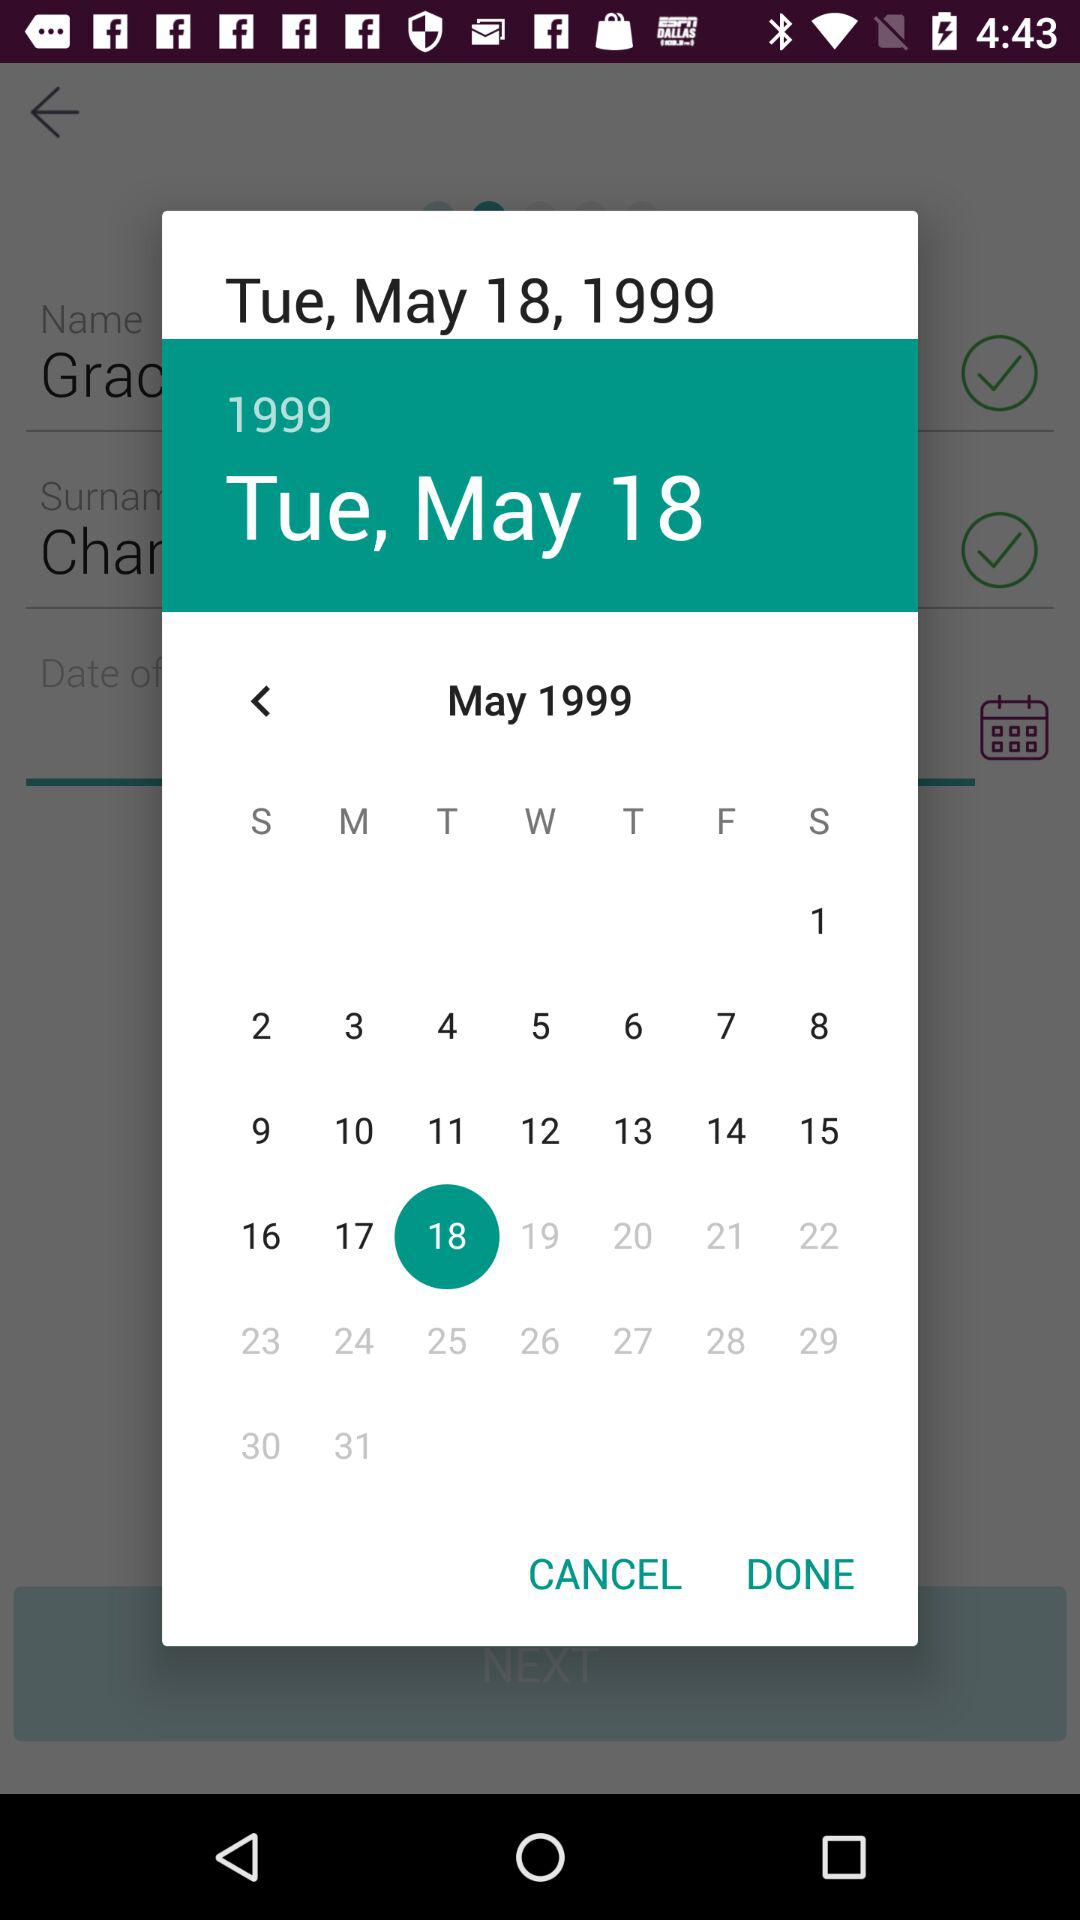What is the date? The date is Tuesday, May 18, 1999. 